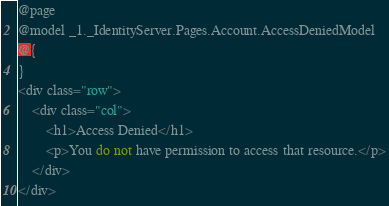Convert code to text. <code><loc_0><loc_0><loc_500><loc_500><_C#_>@page
@model _1._IdentityServer.Pages.Account.AccessDeniedModel
@{
}
<div class="row">
    <div class="col">
        <h1>Access Denied</h1>
        <p>You do not have permission to access that resource.</p>
    </div>
</div></code> 